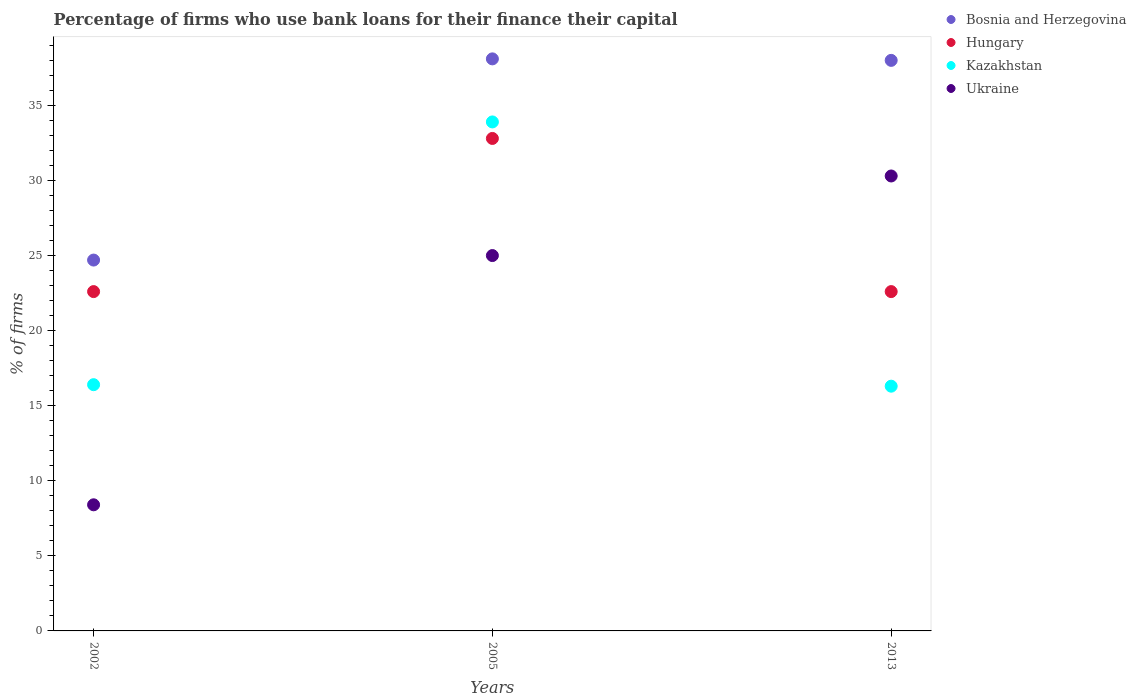What is the percentage of firms who use bank loans for their finance their capital in Bosnia and Herzegovina in 2002?
Provide a short and direct response. 24.7. Across all years, what is the maximum percentage of firms who use bank loans for their finance their capital in Bosnia and Herzegovina?
Your response must be concise. 38.1. Across all years, what is the minimum percentage of firms who use bank loans for their finance their capital in Ukraine?
Your response must be concise. 8.4. What is the total percentage of firms who use bank loans for their finance their capital in Kazakhstan in the graph?
Your answer should be compact. 66.6. What is the difference between the percentage of firms who use bank loans for their finance their capital in Kazakhstan in 2002 and that in 2005?
Give a very brief answer. -17.5. What is the difference between the percentage of firms who use bank loans for their finance their capital in Kazakhstan in 2002 and the percentage of firms who use bank loans for their finance their capital in Hungary in 2013?
Ensure brevity in your answer.  -6.2. What is the average percentage of firms who use bank loans for their finance their capital in Kazakhstan per year?
Provide a succinct answer. 22.2. In the year 2013, what is the difference between the percentage of firms who use bank loans for their finance their capital in Hungary and percentage of firms who use bank loans for their finance their capital in Kazakhstan?
Your answer should be very brief. 6.3. In how many years, is the percentage of firms who use bank loans for their finance their capital in Kazakhstan greater than 19 %?
Your answer should be very brief. 1. What is the ratio of the percentage of firms who use bank loans for their finance their capital in Bosnia and Herzegovina in 2005 to that in 2013?
Your answer should be compact. 1. Is the percentage of firms who use bank loans for their finance their capital in Bosnia and Herzegovina in 2005 less than that in 2013?
Your answer should be very brief. No. Is the difference between the percentage of firms who use bank loans for their finance their capital in Hungary in 2005 and 2013 greater than the difference between the percentage of firms who use bank loans for their finance their capital in Kazakhstan in 2005 and 2013?
Your answer should be very brief. No. What is the difference between the highest and the lowest percentage of firms who use bank loans for their finance their capital in Hungary?
Keep it short and to the point. 10.2. In how many years, is the percentage of firms who use bank loans for their finance their capital in Hungary greater than the average percentage of firms who use bank loans for their finance their capital in Hungary taken over all years?
Your answer should be compact. 1. Is it the case that in every year, the sum of the percentage of firms who use bank loans for their finance their capital in Kazakhstan and percentage of firms who use bank loans for their finance their capital in Ukraine  is greater than the sum of percentage of firms who use bank loans for their finance their capital in Hungary and percentage of firms who use bank loans for their finance their capital in Bosnia and Herzegovina?
Provide a short and direct response. No. Is it the case that in every year, the sum of the percentage of firms who use bank loans for their finance their capital in Kazakhstan and percentage of firms who use bank loans for their finance their capital in Hungary  is greater than the percentage of firms who use bank loans for their finance their capital in Bosnia and Herzegovina?
Offer a terse response. Yes. Does the percentage of firms who use bank loans for their finance their capital in Hungary monotonically increase over the years?
Keep it short and to the point. No. Is the percentage of firms who use bank loans for their finance their capital in Ukraine strictly greater than the percentage of firms who use bank loans for their finance their capital in Hungary over the years?
Offer a terse response. No. How many years are there in the graph?
Offer a very short reply. 3. What is the difference between two consecutive major ticks on the Y-axis?
Make the answer very short. 5. Does the graph contain any zero values?
Your answer should be very brief. No. Does the graph contain grids?
Give a very brief answer. No. What is the title of the graph?
Ensure brevity in your answer.  Percentage of firms who use bank loans for their finance their capital. What is the label or title of the X-axis?
Your answer should be very brief. Years. What is the label or title of the Y-axis?
Your response must be concise. % of firms. What is the % of firms of Bosnia and Herzegovina in 2002?
Give a very brief answer. 24.7. What is the % of firms of Hungary in 2002?
Offer a terse response. 22.6. What is the % of firms of Kazakhstan in 2002?
Your response must be concise. 16.4. What is the % of firms of Bosnia and Herzegovina in 2005?
Give a very brief answer. 38.1. What is the % of firms in Hungary in 2005?
Offer a terse response. 32.8. What is the % of firms of Kazakhstan in 2005?
Offer a terse response. 33.9. What is the % of firms of Ukraine in 2005?
Keep it short and to the point. 25. What is the % of firms in Bosnia and Herzegovina in 2013?
Make the answer very short. 38. What is the % of firms in Hungary in 2013?
Keep it short and to the point. 22.6. What is the % of firms of Kazakhstan in 2013?
Offer a very short reply. 16.3. What is the % of firms of Ukraine in 2013?
Provide a succinct answer. 30.3. Across all years, what is the maximum % of firms of Bosnia and Herzegovina?
Your answer should be very brief. 38.1. Across all years, what is the maximum % of firms in Hungary?
Offer a terse response. 32.8. Across all years, what is the maximum % of firms of Kazakhstan?
Provide a short and direct response. 33.9. Across all years, what is the maximum % of firms of Ukraine?
Provide a short and direct response. 30.3. Across all years, what is the minimum % of firms in Bosnia and Herzegovina?
Ensure brevity in your answer.  24.7. Across all years, what is the minimum % of firms in Hungary?
Your answer should be compact. 22.6. Across all years, what is the minimum % of firms in Ukraine?
Keep it short and to the point. 8.4. What is the total % of firms in Bosnia and Herzegovina in the graph?
Offer a terse response. 100.8. What is the total % of firms in Kazakhstan in the graph?
Keep it short and to the point. 66.6. What is the total % of firms in Ukraine in the graph?
Your answer should be compact. 63.7. What is the difference between the % of firms in Bosnia and Herzegovina in 2002 and that in 2005?
Provide a short and direct response. -13.4. What is the difference between the % of firms of Kazakhstan in 2002 and that in 2005?
Your answer should be compact. -17.5. What is the difference between the % of firms of Ukraine in 2002 and that in 2005?
Keep it short and to the point. -16.6. What is the difference between the % of firms of Bosnia and Herzegovina in 2002 and that in 2013?
Your response must be concise. -13.3. What is the difference between the % of firms in Ukraine in 2002 and that in 2013?
Make the answer very short. -21.9. What is the difference between the % of firms of Hungary in 2005 and that in 2013?
Your answer should be very brief. 10.2. What is the difference between the % of firms in Kazakhstan in 2005 and that in 2013?
Offer a very short reply. 17.6. What is the difference between the % of firms of Ukraine in 2005 and that in 2013?
Make the answer very short. -5.3. What is the difference between the % of firms in Bosnia and Herzegovina in 2002 and the % of firms in Ukraine in 2005?
Keep it short and to the point. -0.3. What is the difference between the % of firms of Hungary in 2002 and the % of firms of Ukraine in 2005?
Your answer should be very brief. -2.4. What is the difference between the % of firms in Bosnia and Herzegovina in 2002 and the % of firms in Kazakhstan in 2013?
Your answer should be compact. 8.4. What is the difference between the % of firms in Bosnia and Herzegovina in 2002 and the % of firms in Ukraine in 2013?
Offer a very short reply. -5.6. What is the difference between the % of firms in Hungary in 2002 and the % of firms in Kazakhstan in 2013?
Give a very brief answer. 6.3. What is the difference between the % of firms in Hungary in 2002 and the % of firms in Ukraine in 2013?
Provide a short and direct response. -7.7. What is the difference between the % of firms in Kazakhstan in 2002 and the % of firms in Ukraine in 2013?
Keep it short and to the point. -13.9. What is the difference between the % of firms of Bosnia and Herzegovina in 2005 and the % of firms of Hungary in 2013?
Provide a short and direct response. 15.5. What is the difference between the % of firms in Bosnia and Herzegovina in 2005 and the % of firms in Kazakhstan in 2013?
Your response must be concise. 21.8. What is the difference between the % of firms in Bosnia and Herzegovina in 2005 and the % of firms in Ukraine in 2013?
Keep it short and to the point. 7.8. What is the difference between the % of firms in Hungary in 2005 and the % of firms in Ukraine in 2013?
Make the answer very short. 2.5. What is the average % of firms of Bosnia and Herzegovina per year?
Give a very brief answer. 33.6. What is the average % of firms of Hungary per year?
Give a very brief answer. 26. What is the average % of firms in Ukraine per year?
Your answer should be very brief. 21.23. In the year 2002, what is the difference between the % of firms of Bosnia and Herzegovina and % of firms of Kazakhstan?
Provide a succinct answer. 8.3. In the year 2002, what is the difference between the % of firms of Hungary and % of firms of Kazakhstan?
Keep it short and to the point. 6.2. In the year 2002, what is the difference between the % of firms in Hungary and % of firms in Ukraine?
Keep it short and to the point. 14.2. In the year 2002, what is the difference between the % of firms in Kazakhstan and % of firms in Ukraine?
Keep it short and to the point. 8. In the year 2005, what is the difference between the % of firms in Bosnia and Herzegovina and % of firms in Kazakhstan?
Make the answer very short. 4.2. In the year 2013, what is the difference between the % of firms of Bosnia and Herzegovina and % of firms of Hungary?
Your response must be concise. 15.4. In the year 2013, what is the difference between the % of firms of Bosnia and Herzegovina and % of firms of Kazakhstan?
Keep it short and to the point. 21.7. In the year 2013, what is the difference between the % of firms in Hungary and % of firms in Kazakhstan?
Offer a terse response. 6.3. In the year 2013, what is the difference between the % of firms of Kazakhstan and % of firms of Ukraine?
Make the answer very short. -14. What is the ratio of the % of firms of Bosnia and Herzegovina in 2002 to that in 2005?
Give a very brief answer. 0.65. What is the ratio of the % of firms in Hungary in 2002 to that in 2005?
Offer a very short reply. 0.69. What is the ratio of the % of firms in Kazakhstan in 2002 to that in 2005?
Your answer should be compact. 0.48. What is the ratio of the % of firms in Ukraine in 2002 to that in 2005?
Offer a very short reply. 0.34. What is the ratio of the % of firms of Bosnia and Herzegovina in 2002 to that in 2013?
Offer a terse response. 0.65. What is the ratio of the % of firms in Hungary in 2002 to that in 2013?
Ensure brevity in your answer.  1. What is the ratio of the % of firms in Ukraine in 2002 to that in 2013?
Ensure brevity in your answer.  0.28. What is the ratio of the % of firms in Bosnia and Herzegovina in 2005 to that in 2013?
Keep it short and to the point. 1. What is the ratio of the % of firms of Hungary in 2005 to that in 2013?
Your response must be concise. 1.45. What is the ratio of the % of firms in Kazakhstan in 2005 to that in 2013?
Provide a succinct answer. 2.08. What is the ratio of the % of firms in Ukraine in 2005 to that in 2013?
Provide a short and direct response. 0.83. What is the difference between the highest and the second highest % of firms of Hungary?
Provide a short and direct response. 10.2. What is the difference between the highest and the second highest % of firms in Kazakhstan?
Provide a succinct answer. 17.5. What is the difference between the highest and the second highest % of firms in Ukraine?
Give a very brief answer. 5.3. What is the difference between the highest and the lowest % of firms in Hungary?
Your answer should be very brief. 10.2. What is the difference between the highest and the lowest % of firms of Ukraine?
Ensure brevity in your answer.  21.9. 